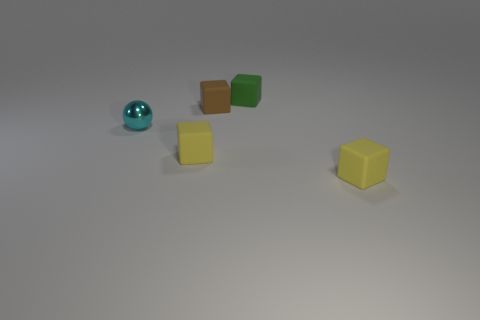There is a yellow object on the left side of the brown matte thing; are there any tiny things that are left of it?
Your answer should be very brief. Yes. What is the tiny brown block made of?
Offer a terse response. Rubber. Are there any tiny brown rubber things in front of the small cyan shiny object?
Provide a succinct answer. No. What is the size of the brown object that is the same shape as the tiny green rubber object?
Offer a very short reply. Small. Are there the same number of cyan things left of the small cyan object and small matte objects right of the green matte block?
Provide a short and direct response. No. How many matte things are there?
Keep it short and to the point. 4. Is the number of things right of the small shiny thing greater than the number of big metal spheres?
Your answer should be very brief. Yes. What is the small block to the right of the small green block made of?
Your answer should be very brief. Rubber. How many matte objects have the same color as the tiny metallic sphere?
Your response must be concise. 0. There is a rubber thing that is behind the tiny brown object; is it the same size as the rubber thing that is on the left side of the tiny brown cube?
Offer a terse response. Yes. 